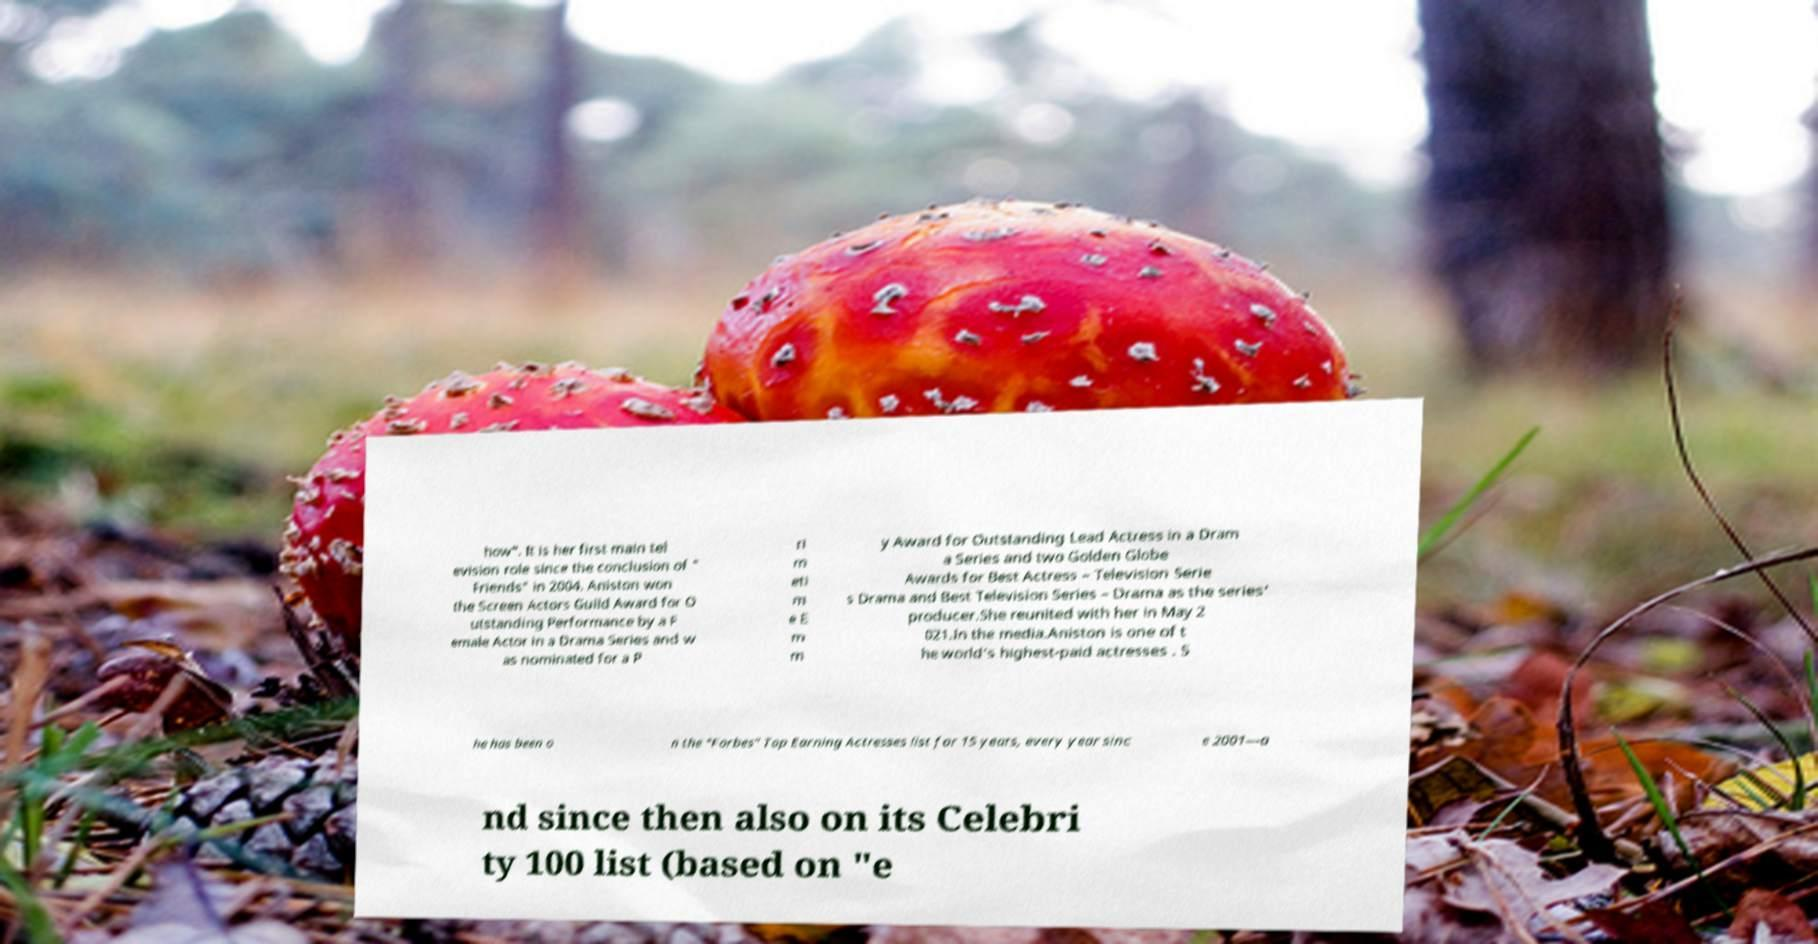Can you read and provide the text displayed in the image?This photo seems to have some interesting text. Can you extract and type it out for me? how". It is her first main tel evision role since the conclusion of " Friends" in 2004. Aniston won the Screen Actors Guild Award for O utstanding Performance by a F emale Actor in a Drama Series and w as nominated for a P ri m eti m e E m m y Award for Outstanding Lead Actress in a Dram a Series and two Golden Globe Awards for Best Actress – Television Serie s Drama and Best Television Series – Drama as the series' producer.She reunited with her in May 2 021.In the media.Aniston is one of t he world's highest-paid actresses . S he has been o n the "Forbes" Top Earning Actresses list for 15 years, every year sinc e 2001—a nd since then also on its Celebri ty 100 list (based on "e 